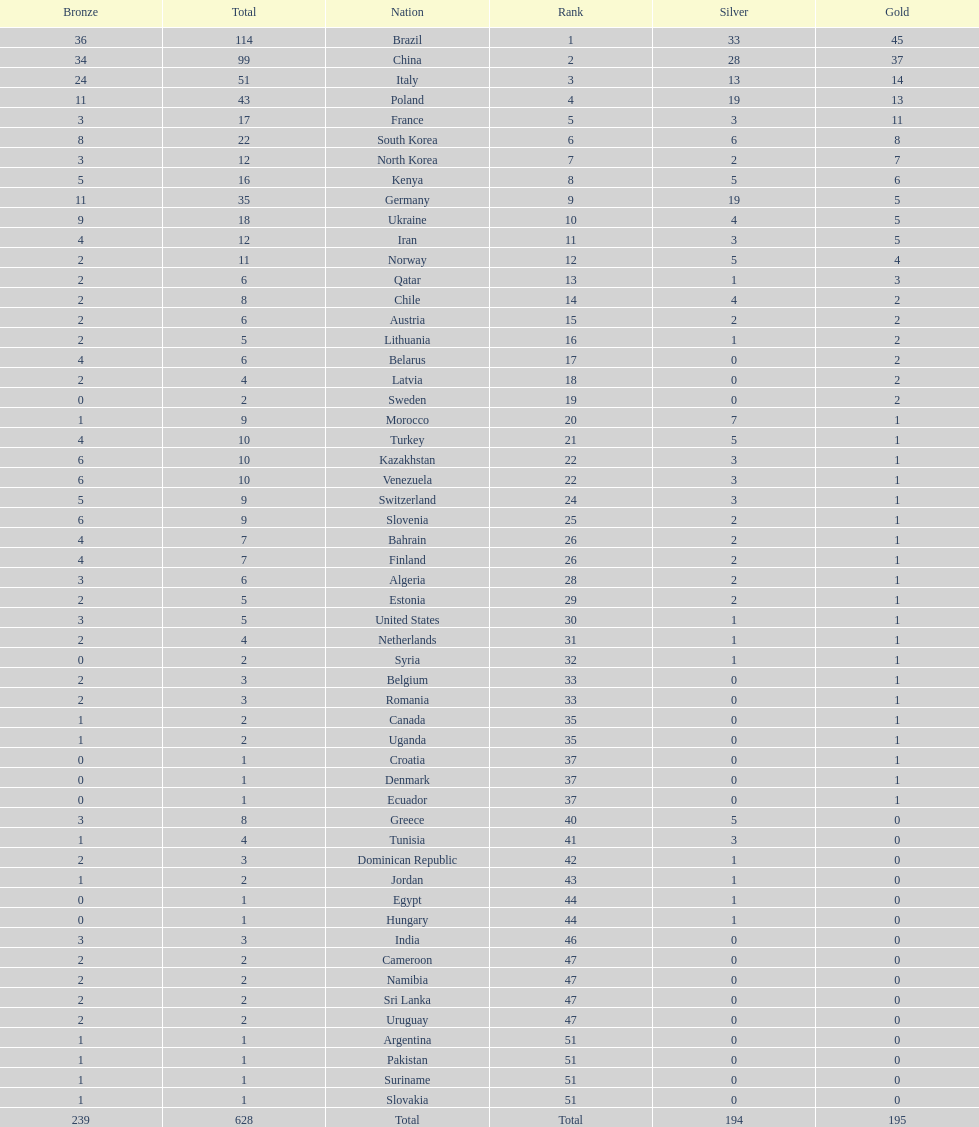Who only won 13 silver medals? Italy. 